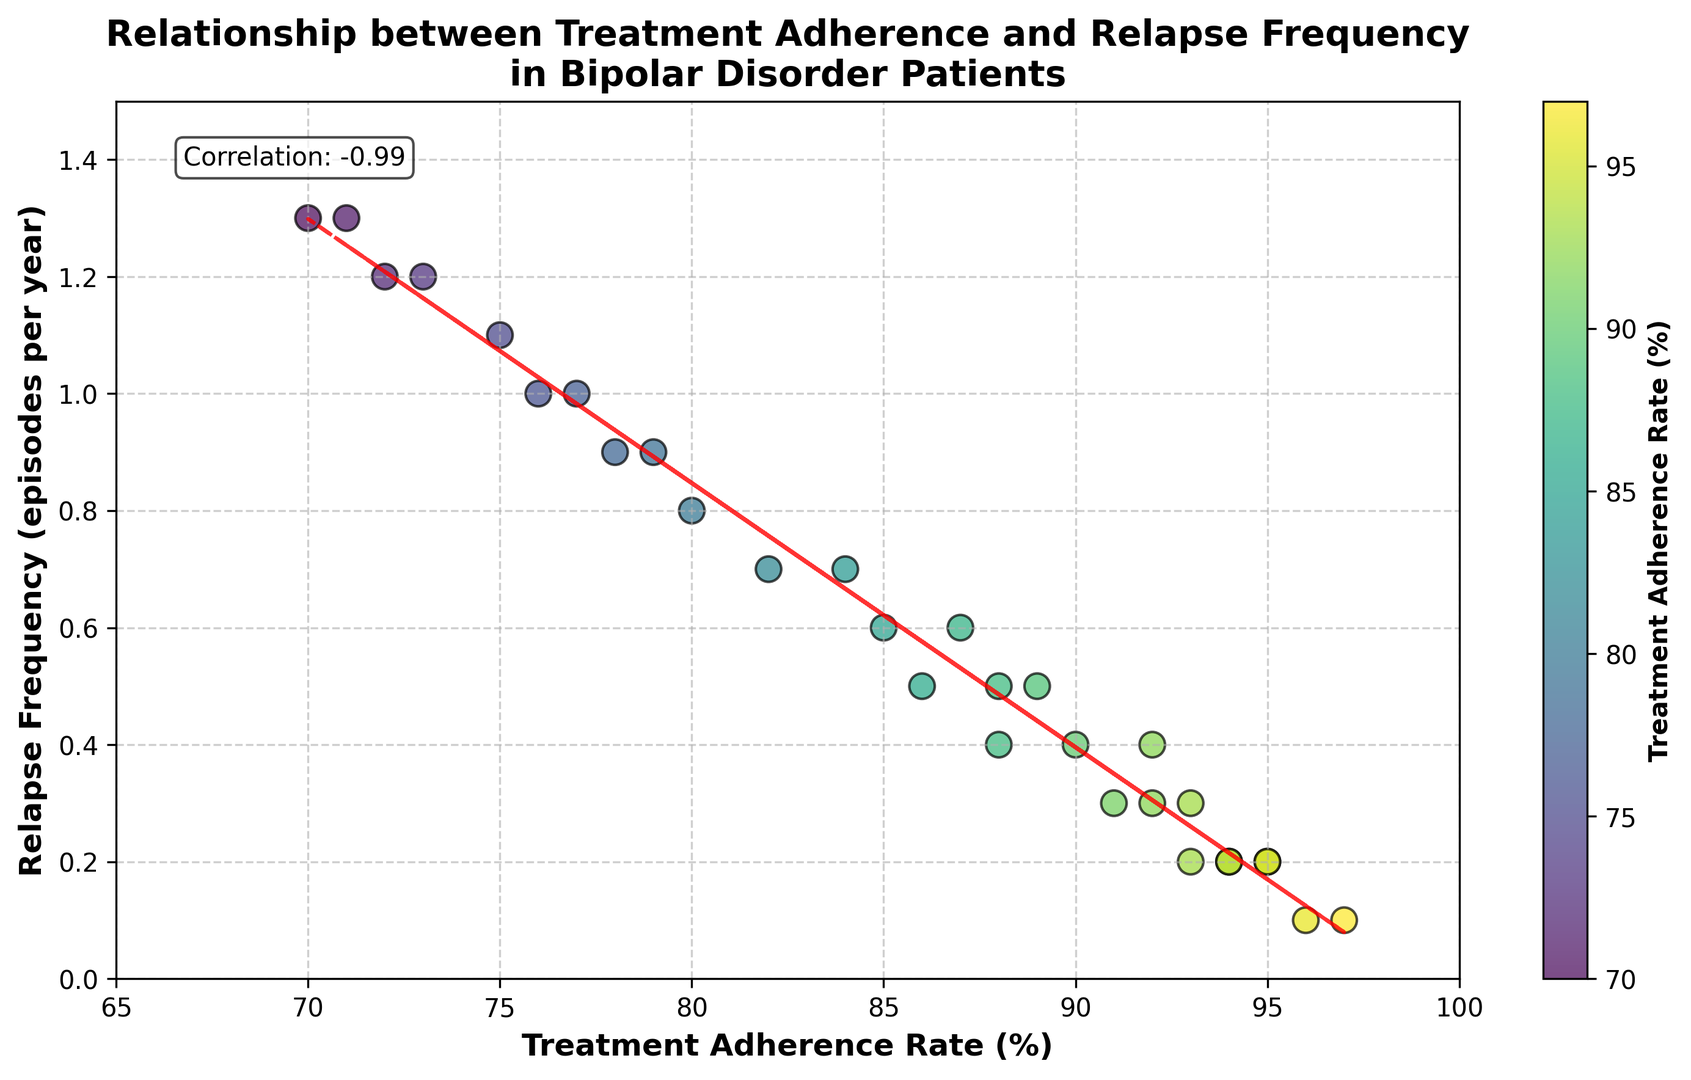What is the correlation coefficient between treatment adherence rate and relapse frequency? The correlation coefficient is provided in the text box on the plot. The correlation is stated as 0.91.
Answer: 0.91 Is there a general trend between treatment adherence rate and relapse frequency? The trendline (red dashed line) indicates that higher treatment adherence rates are associated with lower relapse frequencies, showing a negative correlation.
Answer: Yes, a negative correlation Which data point represents the highest treatment adherence rate and what is its relapse frequency? The data point with the highest treatment adherence rate (97%) corresponds to a relapse frequency of 0.1 episodes per year.
Answer: 97%, 0.1 How many patients have a relapse frequency of less than 0.5 episodes per year? Visual inspection shows the dots below the 0.5 mark. Counting these, we get 14 patients.
Answer: 14 Among the patients with adherence rates between 70% and 80%, what is the range of relapse frequencies? The adherence rates between 70% and 80% have relapse frequencies of 0.9, 1.2, 1.3, 0.8, 1.0, and 0.9. The range is 1.3 - 0.8 = 0.5.
Answer: 0.5 Which adherence rate corresponds to the highest relapse frequency? The highest relapse frequency (1.3 episodes per year) is associated with adherence rates of 70% and 71%.
Answer: 70% and 71% Is there a visible color difference between high and low adherence rates? Higher adherence rates are colored in a brighter, more intense color (closer to yellow), while lower adherence rates are darker (closer to green). This can be inferred from the colorbar gradient.
Answer: Yes What's the average relapse frequency for adherence rates above 90%? The adherence rates above 90% are 92 (0.3), 97 (0.1), 93 (0.2), 94 (0.2), 91 (0.3), 93 (0.3), 94 (0.2), and 95 (0.2). Average =(0.3+0.1+0.2+0.2+0.3+0.3+0.2+0.2)/8 = 1.8/8 = 0.225.
Answer: 0.225 Do any data points have the same relapse frequency but different adherence rates? Yes, multiple points exist with the same relapse frequency but different adherence rates, such as 0.2 with adherence rates of 95%, 93%, 94%, 94%, and 95%.
Answer: Yes 